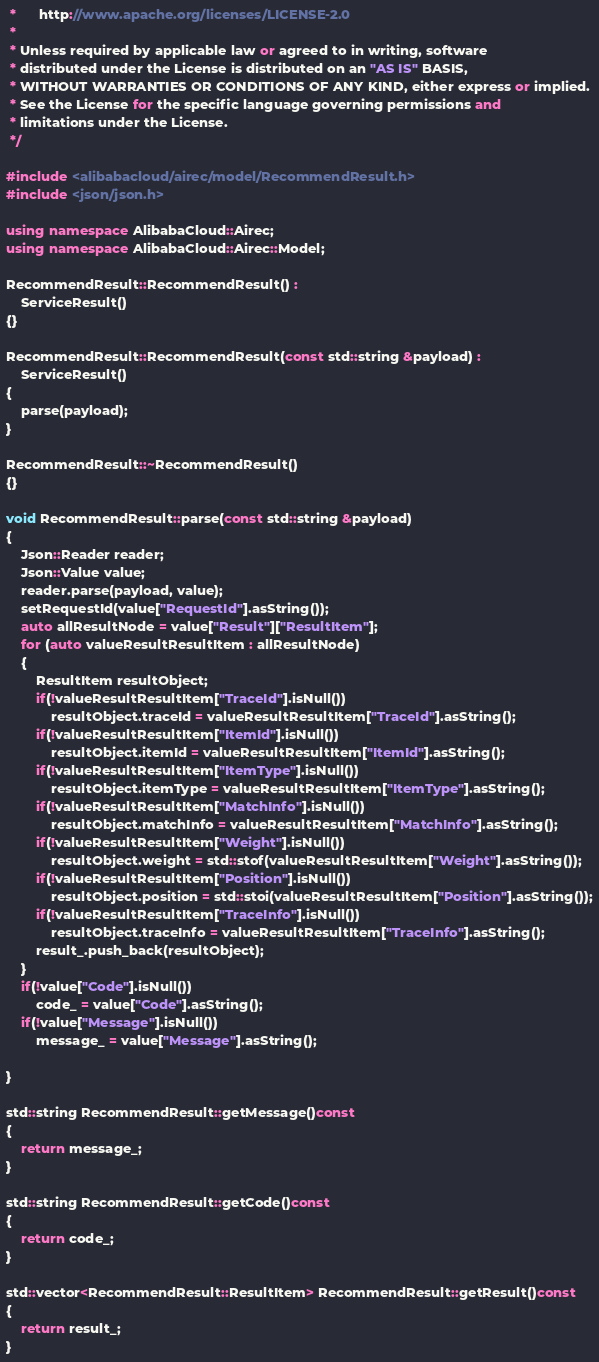<code> <loc_0><loc_0><loc_500><loc_500><_C++_> *      http://www.apache.org/licenses/LICENSE-2.0
 * 
 * Unless required by applicable law or agreed to in writing, software
 * distributed under the License is distributed on an "AS IS" BASIS,
 * WITHOUT WARRANTIES OR CONDITIONS OF ANY KIND, either express or implied.
 * See the License for the specific language governing permissions and
 * limitations under the License.
 */

#include <alibabacloud/airec/model/RecommendResult.h>
#include <json/json.h>

using namespace AlibabaCloud::Airec;
using namespace AlibabaCloud::Airec::Model;

RecommendResult::RecommendResult() :
	ServiceResult()
{}

RecommendResult::RecommendResult(const std::string &payload) :
	ServiceResult()
{
	parse(payload);
}

RecommendResult::~RecommendResult()
{}

void RecommendResult::parse(const std::string &payload)
{
	Json::Reader reader;
	Json::Value value;
	reader.parse(payload, value);
	setRequestId(value["RequestId"].asString());
	auto allResultNode = value["Result"]["ResultItem"];
	for (auto valueResultResultItem : allResultNode)
	{
		ResultItem resultObject;
		if(!valueResultResultItem["TraceId"].isNull())
			resultObject.traceId = valueResultResultItem["TraceId"].asString();
		if(!valueResultResultItem["ItemId"].isNull())
			resultObject.itemId = valueResultResultItem["ItemId"].asString();
		if(!valueResultResultItem["ItemType"].isNull())
			resultObject.itemType = valueResultResultItem["ItemType"].asString();
		if(!valueResultResultItem["MatchInfo"].isNull())
			resultObject.matchInfo = valueResultResultItem["MatchInfo"].asString();
		if(!valueResultResultItem["Weight"].isNull())
			resultObject.weight = std::stof(valueResultResultItem["Weight"].asString());
		if(!valueResultResultItem["Position"].isNull())
			resultObject.position = std::stoi(valueResultResultItem["Position"].asString());
		if(!valueResultResultItem["TraceInfo"].isNull())
			resultObject.traceInfo = valueResultResultItem["TraceInfo"].asString();
		result_.push_back(resultObject);
	}
	if(!value["Code"].isNull())
		code_ = value["Code"].asString();
	if(!value["Message"].isNull())
		message_ = value["Message"].asString();

}

std::string RecommendResult::getMessage()const
{
	return message_;
}

std::string RecommendResult::getCode()const
{
	return code_;
}

std::vector<RecommendResult::ResultItem> RecommendResult::getResult()const
{
	return result_;
}

</code> 